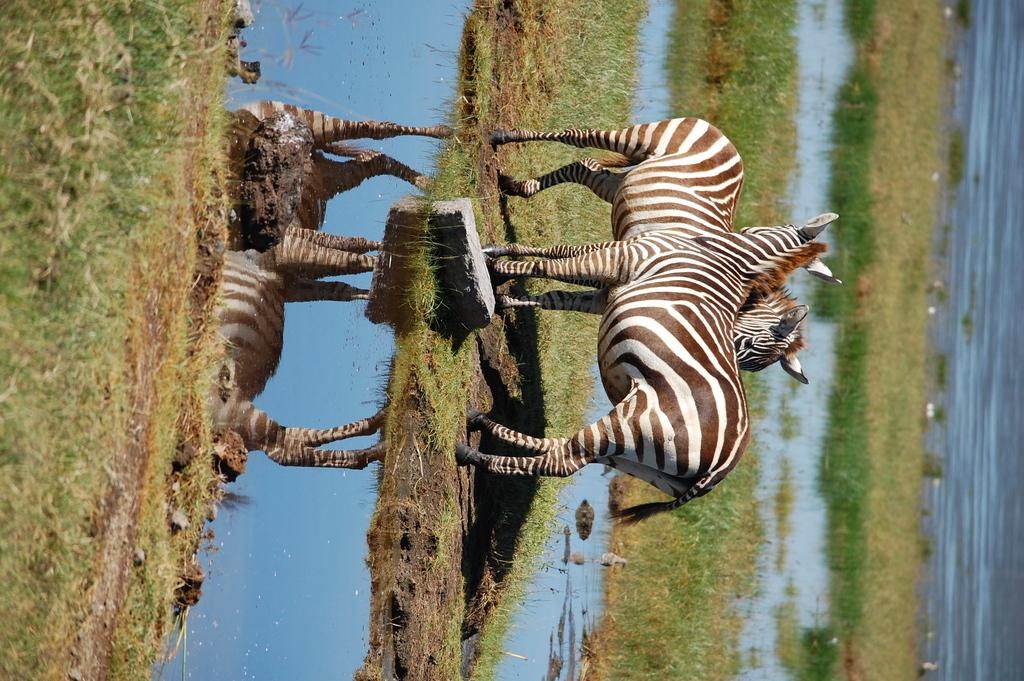What animals can be seen in the image? There are zebras in the image. What is the surface that the zebras are standing on? The zebras are on a surface, but the specific type of surface is not mentioned in the facts. What type of vegetation is present in the image? There is green grass in the image. What else can be seen in the image besides the zebras and grass? There is water visible in the image. Where is the jail located in the image? There is no jail present in the image; it features zebras, green grass, and water. What type of boundary can be seen in the image? There is no boundary mentioned or visible in the image. 